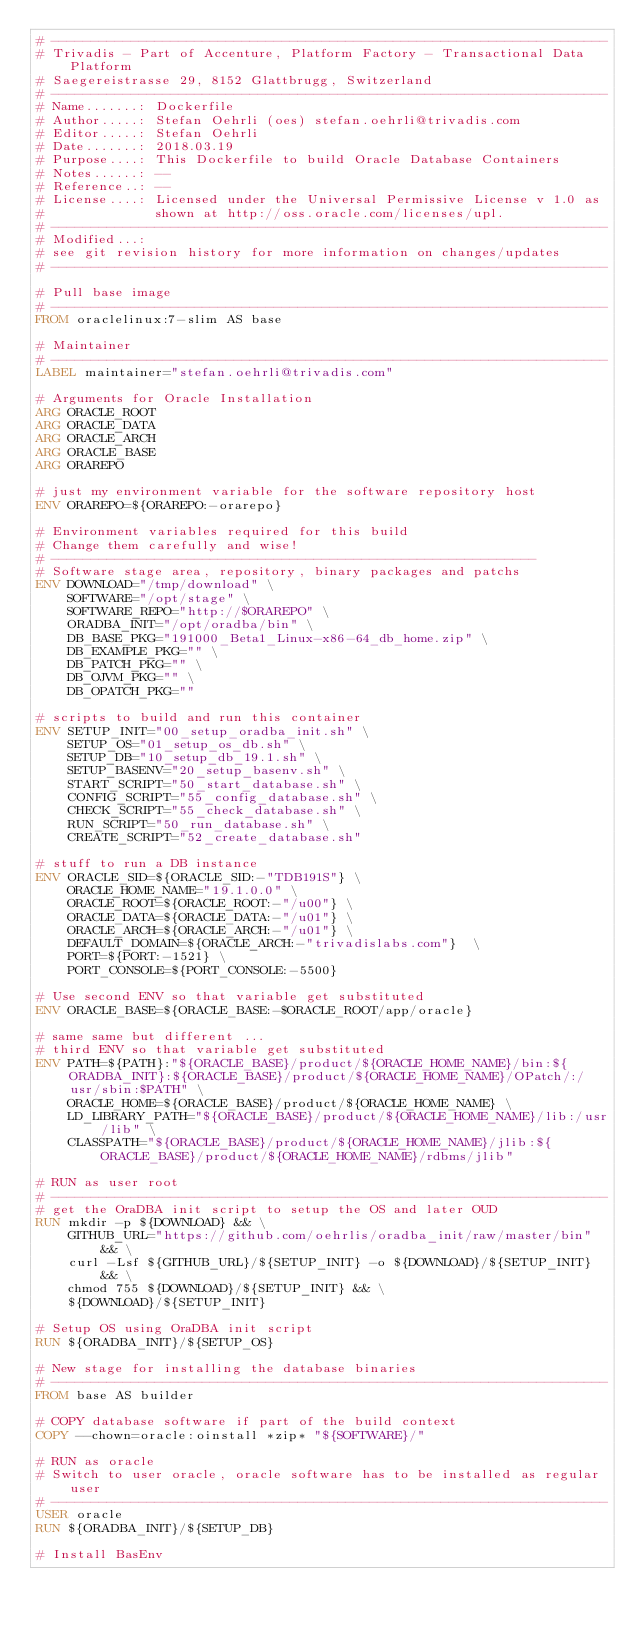<code> <loc_0><loc_0><loc_500><loc_500><_Dockerfile_># ----------------------------------------------------------------------
# Trivadis - Part of Accenture, Platform Factory - Transactional Data Platform
# Saegereistrasse 29, 8152 Glattbrugg, Switzerland
# ----------------------------------------------------------------------
# Name.......: Dockerfile
# Author.....: Stefan Oehrli (oes) stefan.oehrli@trivadis.com
# Editor.....: Stefan Oehrli
# Date.......: 2018.03.19
# Purpose....: This Dockerfile to build Oracle Database Containers
# Notes......: --
# Reference..: --
# License....: Licensed under the Universal Permissive License v 1.0 as
#              shown at http://oss.oracle.com/licenses/upl.
# ----------------------------------------------------------------------
# Modified...:
# see git revision history for more information on changes/updates
# ----------------------------------------------------------------------

# Pull base image
# ----------------------------------------------------------------------
FROM oraclelinux:7-slim AS base

# Maintainer
# ----------------------------------------------------------------------
LABEL maintainer="stefan.oehrli@trivadis.com"

# Arguments for Oracle Installation
ARG ORACLE_ROOT
ARG ORACLE_DATA
ARG ORACLE_ARCH
ARG ORACLE_BASE
ARG ORAREPO

# just my environment variable for the software repository host
ENV ORAREPO=${ORAREPO:-orarepo}

# Environment variables required for this build 
# Change them carefully and wise!
# -------------------------------------------------------------
# Software stage area, repository, binary packages and patchs
ENV DOWNLOAD="/tmp/download" \
    SOFTWARE="/opt/stage" \
    SOFTWARE_REPO="http://$ORAREPO" \
    ORADBA_INIT="/opt/oradba/bin" \
    DB_BASE_PKG="191000_Beta1_Linux-x86-64_db_home.zip" \
    DB_EXAMPLE_PKG="" \
    DB_PATCH_PKG="" \
    DB_OJVM_PKG="" \
    DB_OPATCH_PKG=""

# scripts to build and run this container
ENV SETUP_INIT="00_setup_oradba_init.sh" \
    SETUP_OS="01_setup_os_db.sh" \
    SETUP_DB="10_setup_db_19.1.sh" \
    SETUP_BASENV="20_setup_basenv.sh" \
    START_SCRIPT="50_start_database.sh" \
    CONFIG_SCRIPT="55_config_database.sh" \
    CHECK_SCRIPT="55_check_database.sh" \
    RUN_SCRIPT="50_run_database.sh" \
    CREATE_SCRIPT="52_create_database.sh"

# stuff to run a DB instance
ENV ORACLE_SID=${ORACLE_SID:-"TDB191S"} \
    ORACLE_HOME_NAME="19.1.0.0" \
    ORACLE_ROOT=${ORACLE_ROOT:-"/u00"} \
    ORACLE_DATA=${ORACLE_DATA:-"/u01"} \
    ORACLE_ARCH=${ORACLE_ARCH:-"/u01"} \
    DEFAULT_DOMAIN=${ORACLE_ARCH:-"trivadislabs.com"}  \
    PORT=${PORT:-1521} \
    PORT_CONSOLE=${PORT_CONSOLE:-5500}

# Use second ENV so that variable get substituted
ENV ORACLE_BASE=${ORACLE_BASE:-$ORACLE_ROOT/app/oracle} 

# same same but different ...
# third ENV so that variable get substituted
ENV PATH=${PATH}:"${ORACLE_BASE}/product/${ORACLE_HOME_NAME}/bin:${ORADBA_INIT}:${ORACLE_BASE}/product/${ORACLE_HOME_NAME}/OPatch/:/usr/sbin:$PATH" \
    ORACLE_HOME=${ORACLE_BASE}/product/${ORACLE_HOME_NAME} \
    LD_LIBRARY_PATH="${ORACLE_BASE}/product/${ORACLE_HOME_NAME}/lib:/usr/lib" \
    CLASSPATH="${ORACLE_BASE}/product/${ORACLE_HOME_NAME}/jlib:${ORACLE_BASE}/product/${ORACLE_HOME_NAME}/rdbms/jlib"

# RUN as user root
# ----------------------------------------------------------------------
# get the OraDBA init script to setup the OS and later OUD
RUN mkdir -p ${DOWNLOAD} && \
    GITHUB_URL="https://github.com/oehrlis/oradba_init/raw/master/bin" && \
    curl -Lsf ${GITHUB_URL}/${SETUP_INIT} -o ${DOWNLOAD}/${SETUP_INIT} && \
    chmod 755 ${DOWNLOAD}/${SETUP_INIT} && \
    ${DOWNLOAD}/${SETUP_INIT}

# Setup OS using OraDBA init script
RUN ${ORADBA_INIT}/${SETUP_OS}

# New stage for installing the database binaries
# ----------------------------------------------------------------------
FROM base AS builder

# COPY database software if part of the build context
COPY --chown=oracle:oinstall *zip* "${SOFTWARE}/"

# RUN as oracle
# Switch to user oracle, oracle software has to be installed as regular user
# ----------------------------------------------------------------------
USER oracle
RUN ${ORADBA_INIT}/${SETUP_DB}

# Install BasEnv</code> 